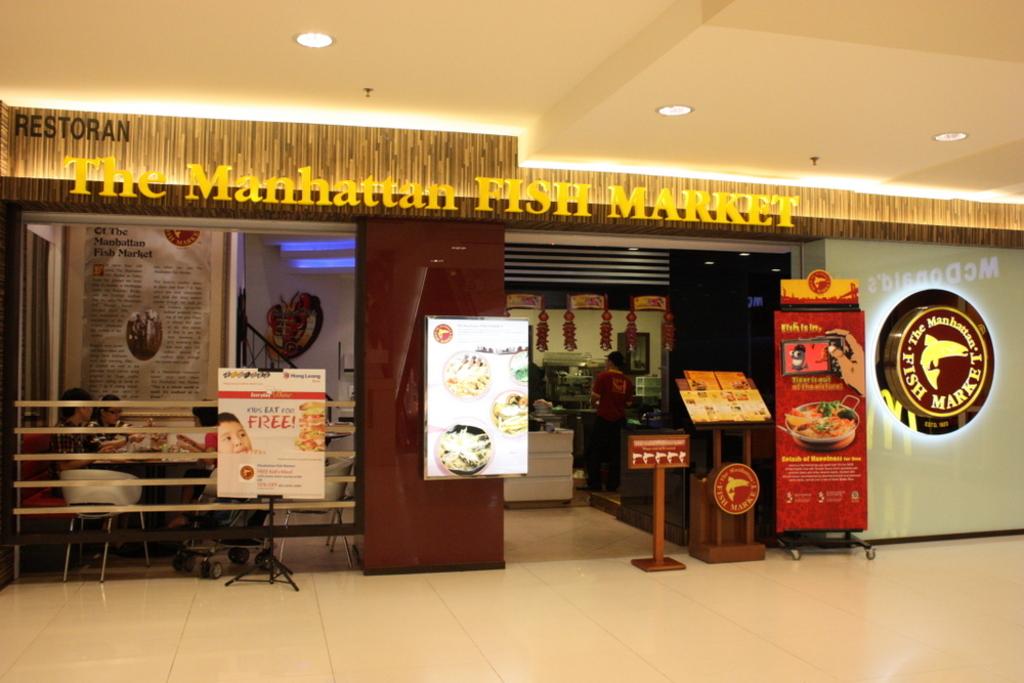What is this a market for?
Provide a succinct answer. Fish. Which fast food restaurant is shown?
Offer a very short reply. The manhattan fish market. 